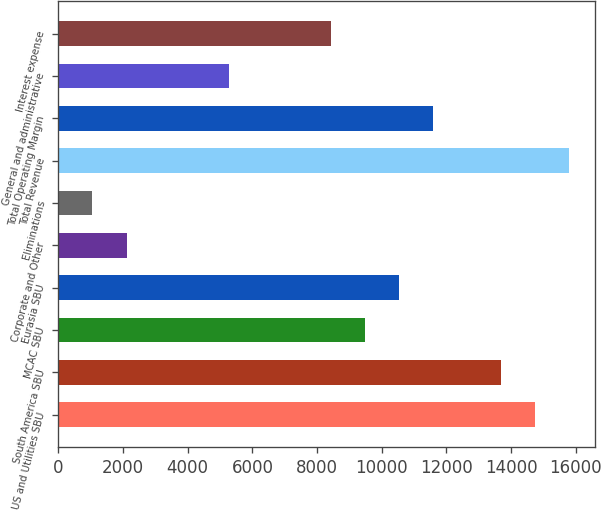<chart> <loc_0><loc_0><loc_500><loc_500><bar_chart><fcel>US and Utilities SBU<fcel>South America SBU<fcel>MCAC SBU<fcel>Eurasia SBU<fcel>Corporate and Other<fcel>Eliminations<fcel>Total Revenue<fcel>Total Operating Margin<fcel>General and administrative<fcel>Interest expense<nl><fcel>14741.8<fcel>13688.8<fcel>9477.04<fcel>10530<fcel>2106.39<fcel>1053.44<fcel>15794.7<fcel>11582.9<fcel>5265.24<fcel>8424.09<nl></chart> 